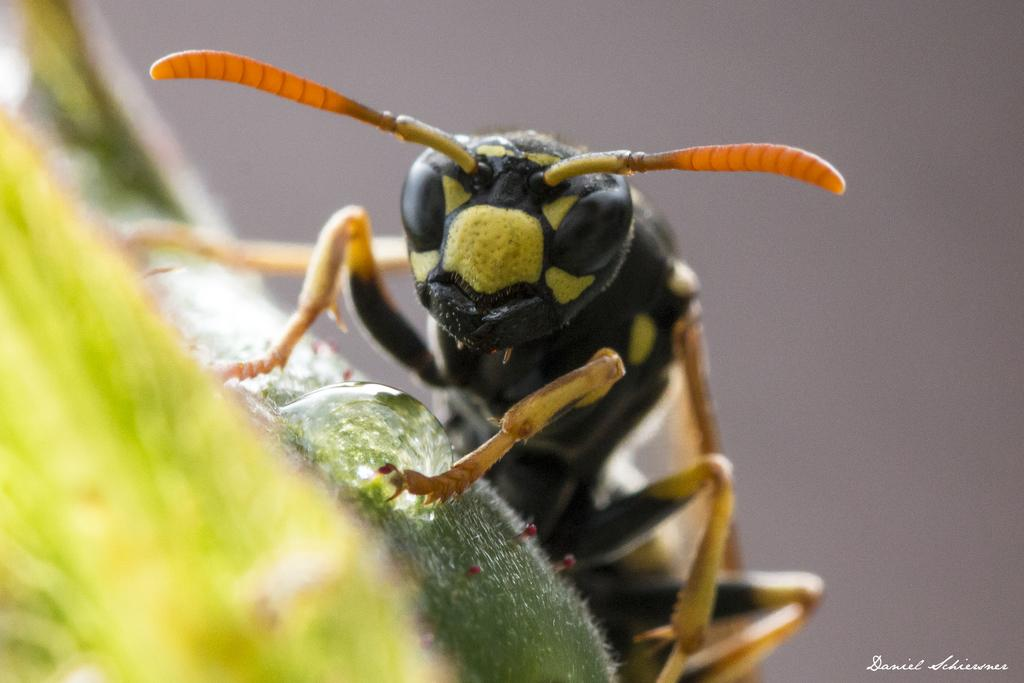What type of creature can be seen in the image? There is an insect in the image. What is the insect interacting with in the image? There is a water droplet in the image that the insect may be interacting with. What type of crate is visible in the image? There is no crate present in the image. Can you see a trail left by the insect in the image? There is no trail left by the insect visible in the image. 